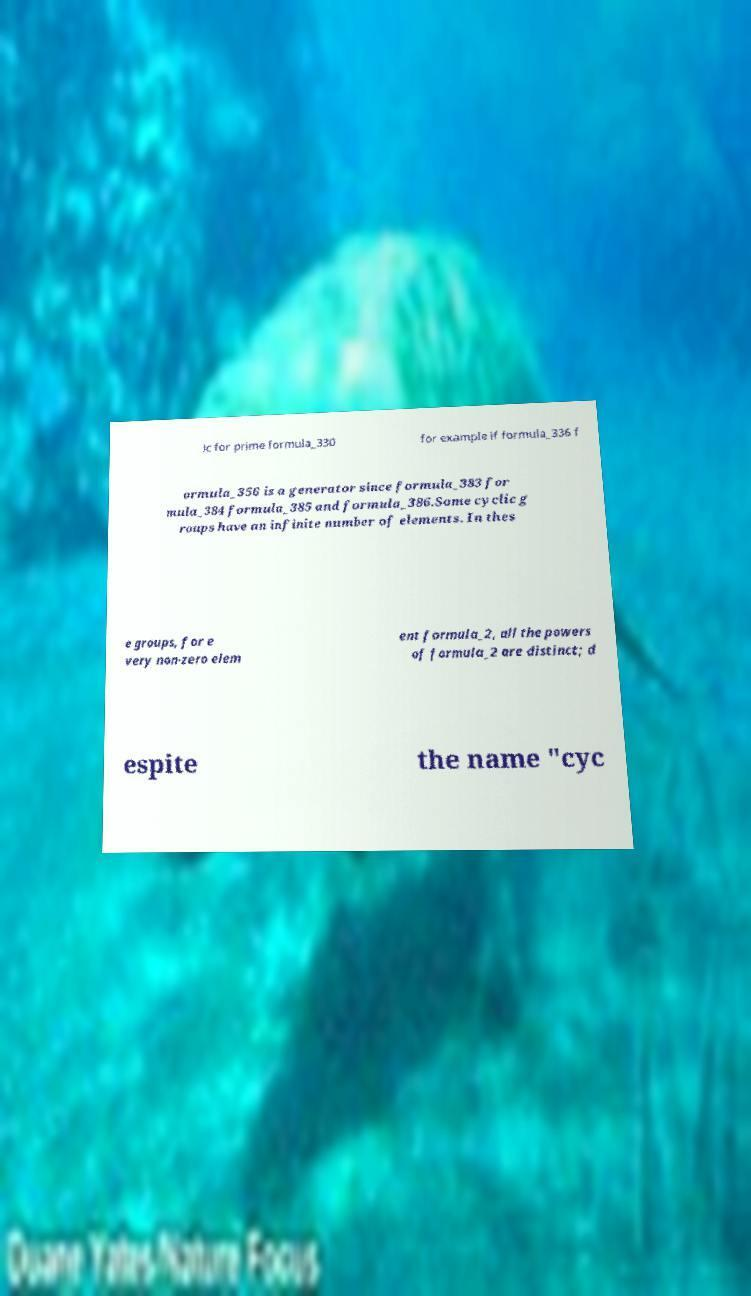For documentation purposes, I need the text within this image transcribed. Could you provide that? ic for prime formula_330 for example if formula_336 f ormula_356 is a generator since formula_383 for mula_384 formula_385 and formula_386.Some cyclic g roups have an infinite number of elements. In thes e groups, for e very non-zero elem ent formula_2, all the powers of formula_2 are distinct; d espite the name "cyc 